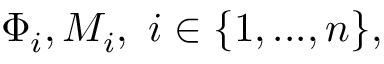Convert formula to latex. <formula><loc_0><loc_0><loc_500><loc_500>\Phi _ { i } , M _ { i } , i \in \{ 1 , \dots , n \} ,</formula> 